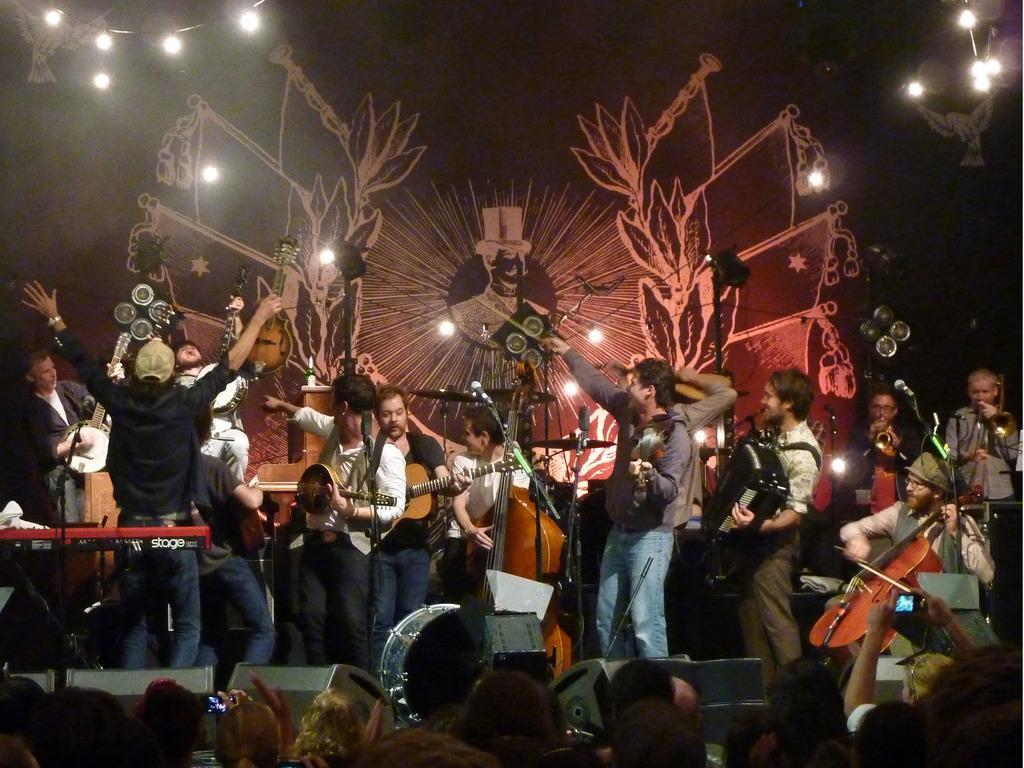Can you describe this image briefly? In this image we can see few persons are standing on the stage and among them few persons are playing musical instruments and there is a piano on a stand, microphones on the stands and other objects. At the bottom we can see few persons heads. In the background we can see lights and drawing on a platform and the image is dark. 